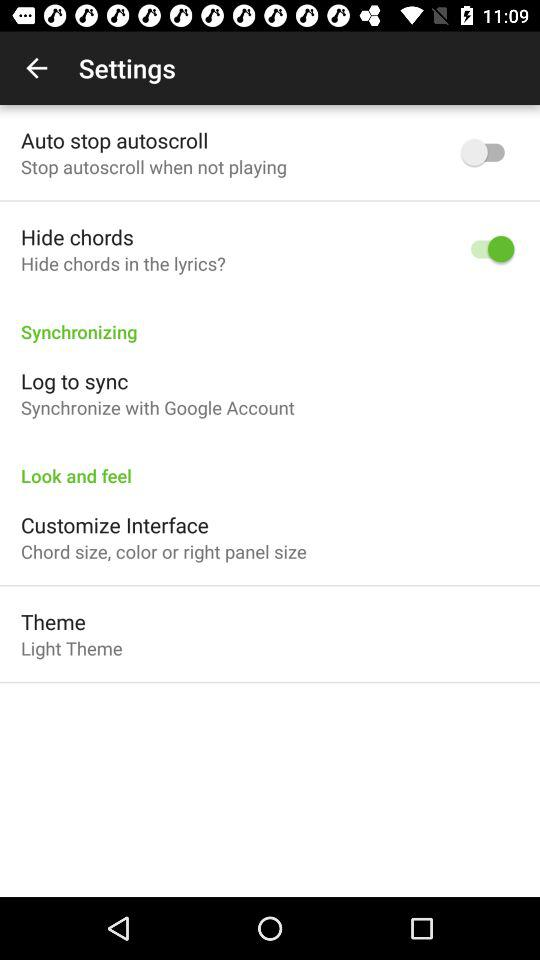Which theme is selected? The selected theme is "Light Theme". 